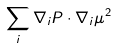Convert formula to latex. <formula><loc_0><loc_0><loc_500><loc_500>\sum _ { i } \nabla _ { i } P \cdot \nabla _ { i } \mu ^ { 2 }</formula> 